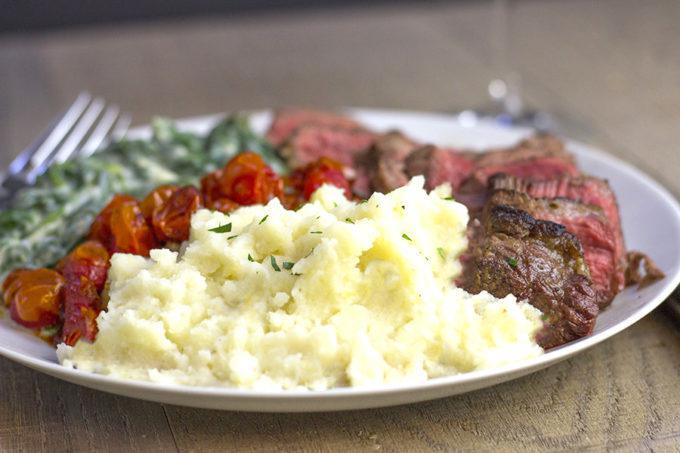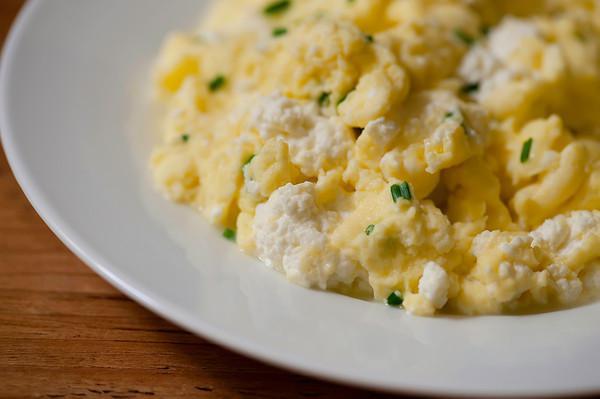The first image is the image on the left, the second image is the image on the right. Evaluate the accuracy of this statement regarding the images: "A fork sits near a plate of food in one of the images.". Is it true? Answer yes or no. Yes. The first image is the image on the left, the second image is the image on the right. Assess this claim about the two images: "Mashed potatoes in each image are served in round white dishes with flecks of garnish.". Correct or not? Answer yes or no. Yes. 